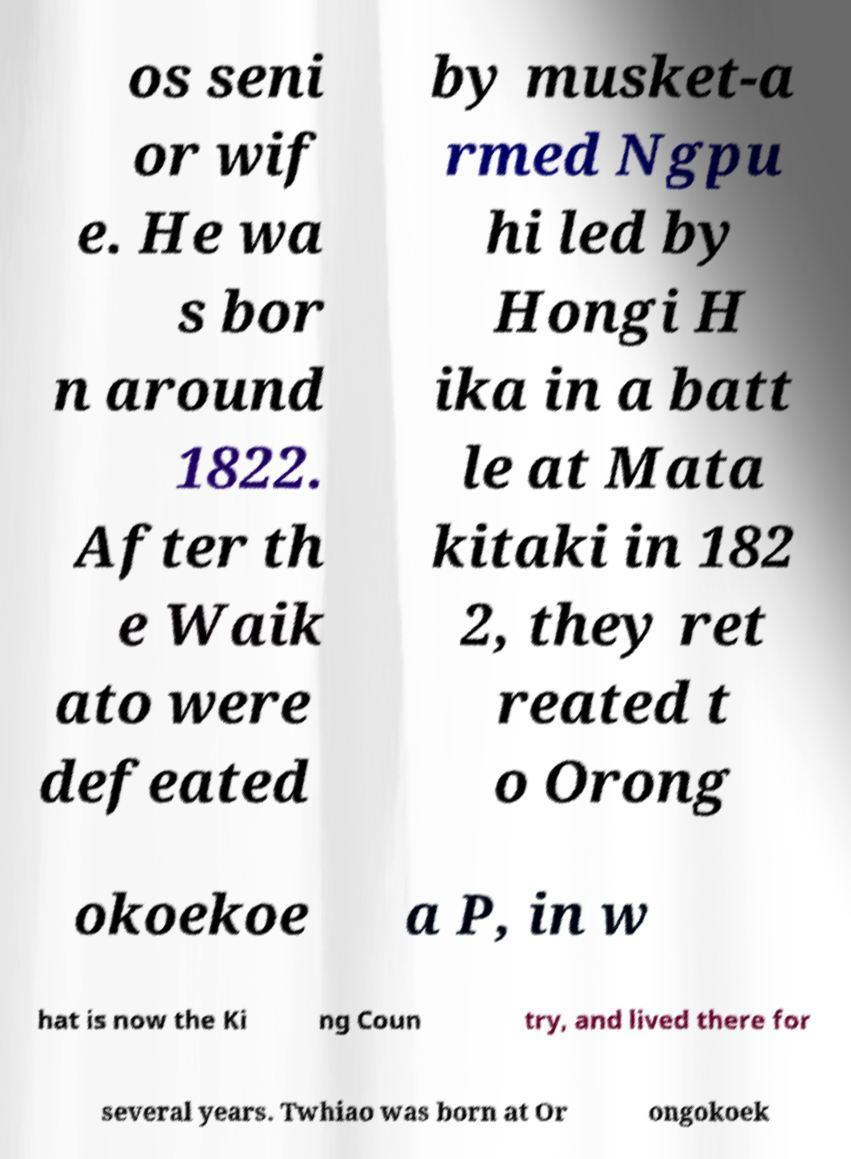Could you assist in decoding the text presented in this image and type it out clearly? os seni or wif e. He wa s bor n around 1822. After th e Waik ato were defeated by musket-a rmed Ngpu hi led by Hongi H ika in a batt le at Mata kitaki in 182 2, they ret reated t o Orong okoekoe a P, in w hat is now the Ki ng Coun try, and lived there for several years. Twhiao was born at Or ongokoek 